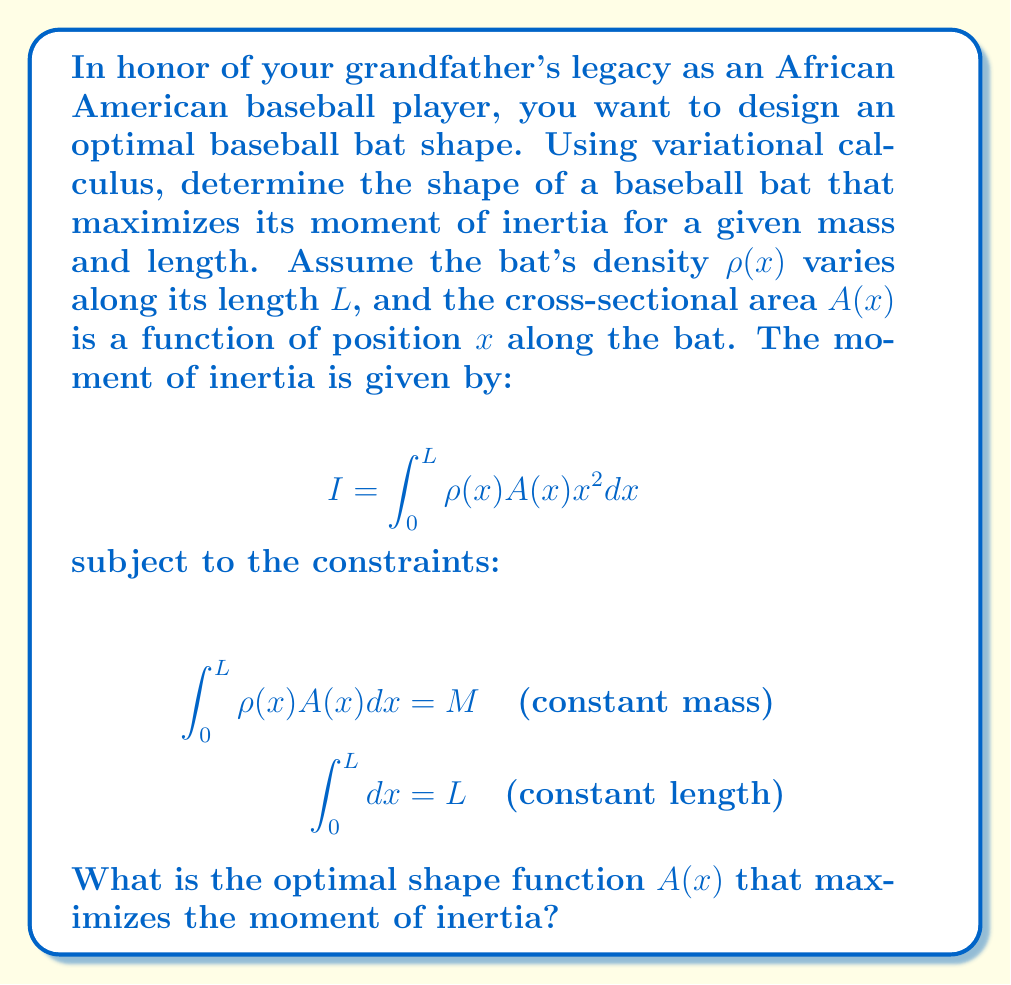Help me with this question. To solve this problem using variational calculus, we'll follow these steps:

1) Form the augmented functional with Lagrange multipliers:
   $$J[A(x)] = \int_0^L [\rho(x) A(x) x^2 + \lambda_1 \rho(x) A(x) + \lambda_2] dx$$

2) Apply the Euler-Lagrange equation:
   $$\frac{\partial}{\partial A} (\rho(x) A(x) x^2 + \lambda_1 \rho(x) A(x) + \lambda_2) = 0$$

3) Simplify:
   $$\rho(x) x^2 + \lambda_1 \rho(x) = 0$$

4) Solve for $A(x)$:
   $$A(x) = k \cdot \frac{1}{x^2 + \lambda_1}$$
   where $k$ is a constant.

5) To determine $k$ and $\lambda_1$, use the constraints:
   $$M = \int_0^L \rho(x) k \cdot \frac{1}{x^2 + \lambda_1} dx$$
   $$L = \int_0^L dx$$

6) The optimal shape function $A(x)$ is inversely proportional to $x^2 + \lambda_1$, where $\lambda_1$ is a constant determined by the mass and length constraints.

This result shows that the optimal bat shape should have a thicker handle and a thinner barrel, with the cross-sectional area decreasing as we move away from the handle.
Answer: $A(x) = k \cdot \frac{1}{x^2 + \lambda_1}$, where $k$ and $\lambda_1$ are constants determined by mass and length constraints. 